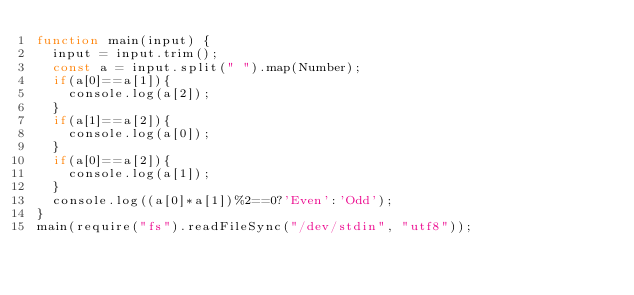Convert code to text. <code><loc_0><loc_0><loc_500><loc_500><_JavaScript_>function main(input) {
  input = input.trim();
  const a = input.split(" ").map(Number);
  if(a[0]==a[1]){
    console.log(a[2]);
  }
  if(a[1]==a[2]){
    console.log(a[0]);
  }
  if(a[0]==a[2]){
    console.log(a[1]);
  }      
  console.log((a[0]*a[1])%2==0?'Even':'Odd');
}
main(require("fs").readFileSync("/dev/stdin", "utf8"));
</code> 